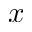<formula> <loc_0><loc_0><loc_500><loc_500>x</formula> 